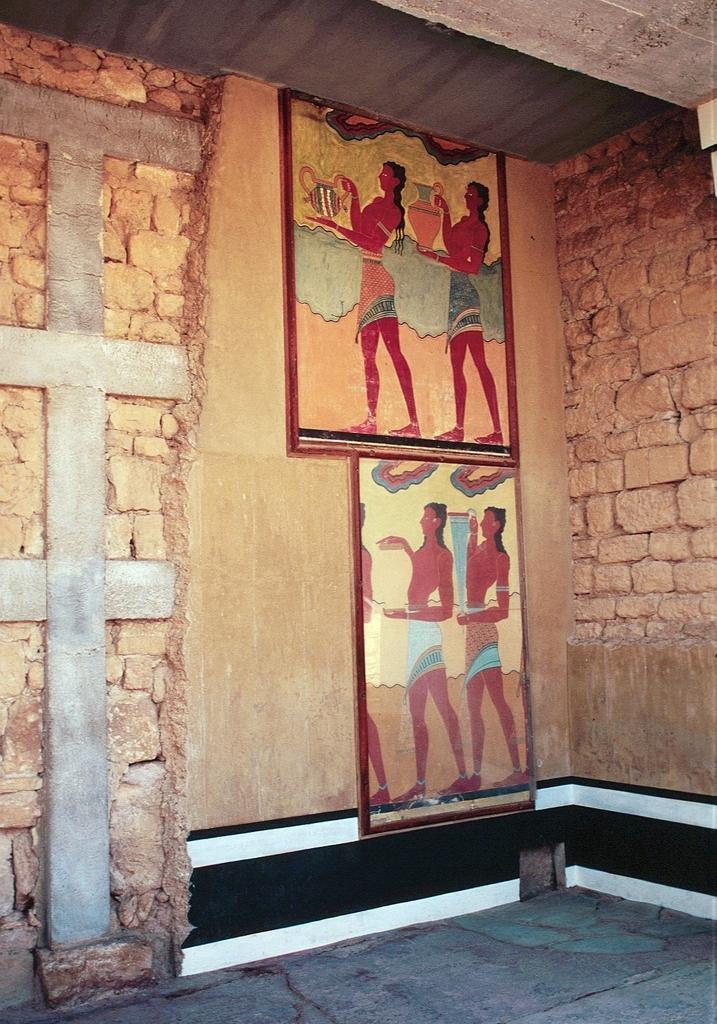Can you describe this image briefly? In this mage we can see wall hangings attached to the wall and the wall is built with cobblestones. 